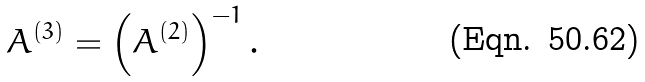<formula> <loc_0><loc_0><loc_500><loc_500>A ^ { ( 3 ) } = \left ( A ^ { ( 2 ) } \right ) ^ { - 1 } .</formula> 